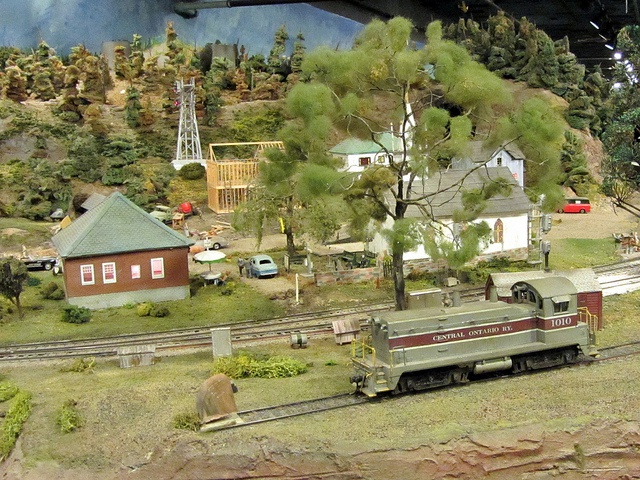Describe the objects in this image and their specific colors. I can see train in gray, darkgray, and beige tones, car in gray, beige, black, and darkgray tones, truck in gray, tan, olive, beige, and black tones, car in gray, black, and darkgray tones, and car in gray and tan tones in this image. 